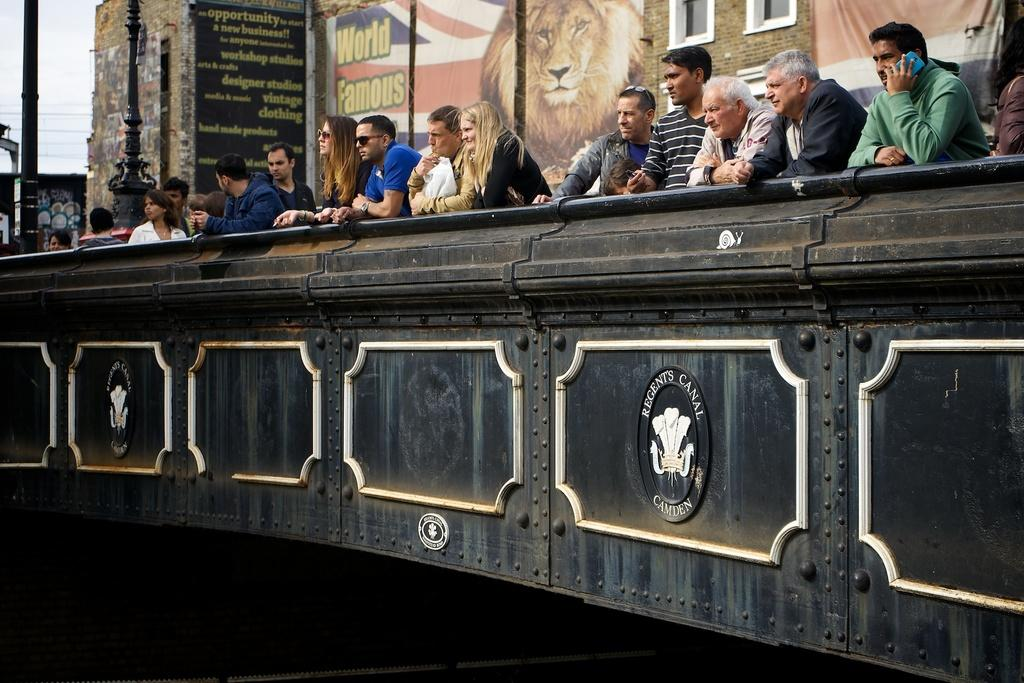Provide a one-sentence caption for the provided image. People are looking out over a bridge that says Regent Canal Camden. 